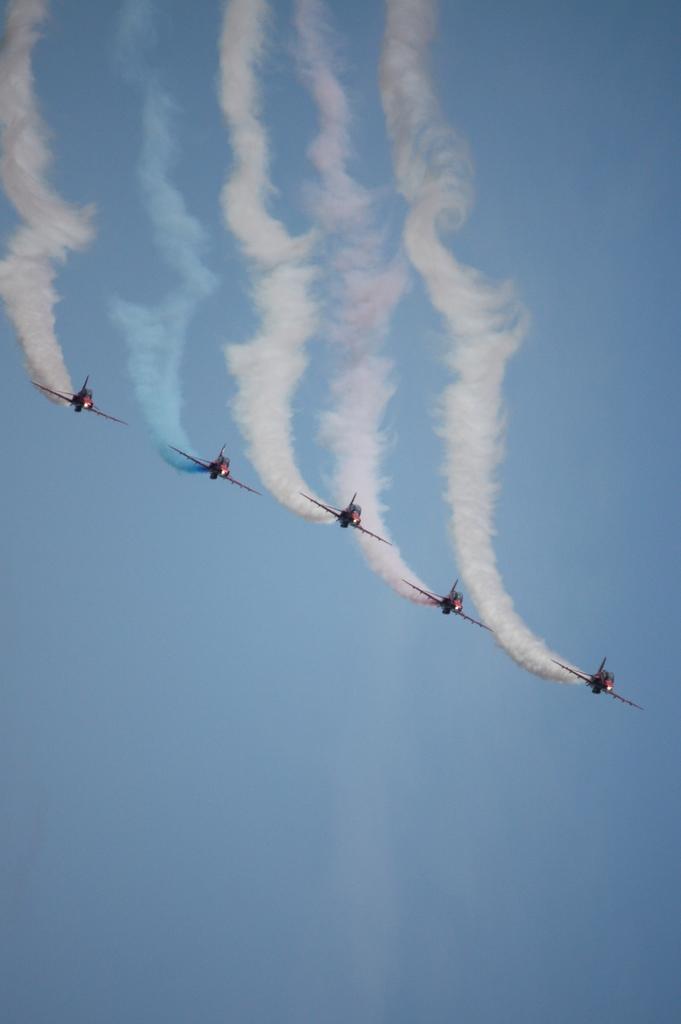Can you describe this image briefly? This picture consists of there are five rockets flying in the air , there is a colorful smoke visible in the middle, there is the sky visible in the middle. 